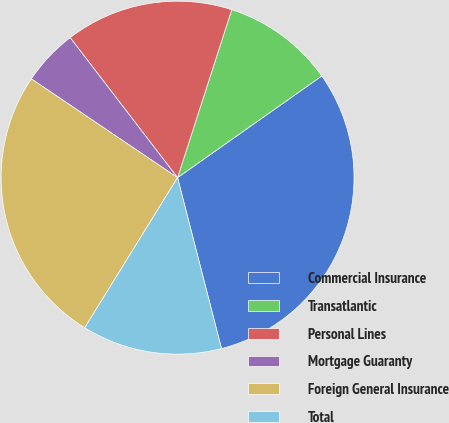Convert chart to OTSL. <chart><loc_0><loc_0><loc_500><loc_500><pie_chart><fcel>Commercial Insurance<fcel>Transatlantic<fcel>Personal Lines<fcel>Mortgage Guaranty<fcel>Foreign General Insurance<fcel>Total<nl><fcel>30.77%<fcel>10.26%<fcel>15.38%<fcel>5.13%<fcel>25.64%<fcel>12.82%<nl></chart> 